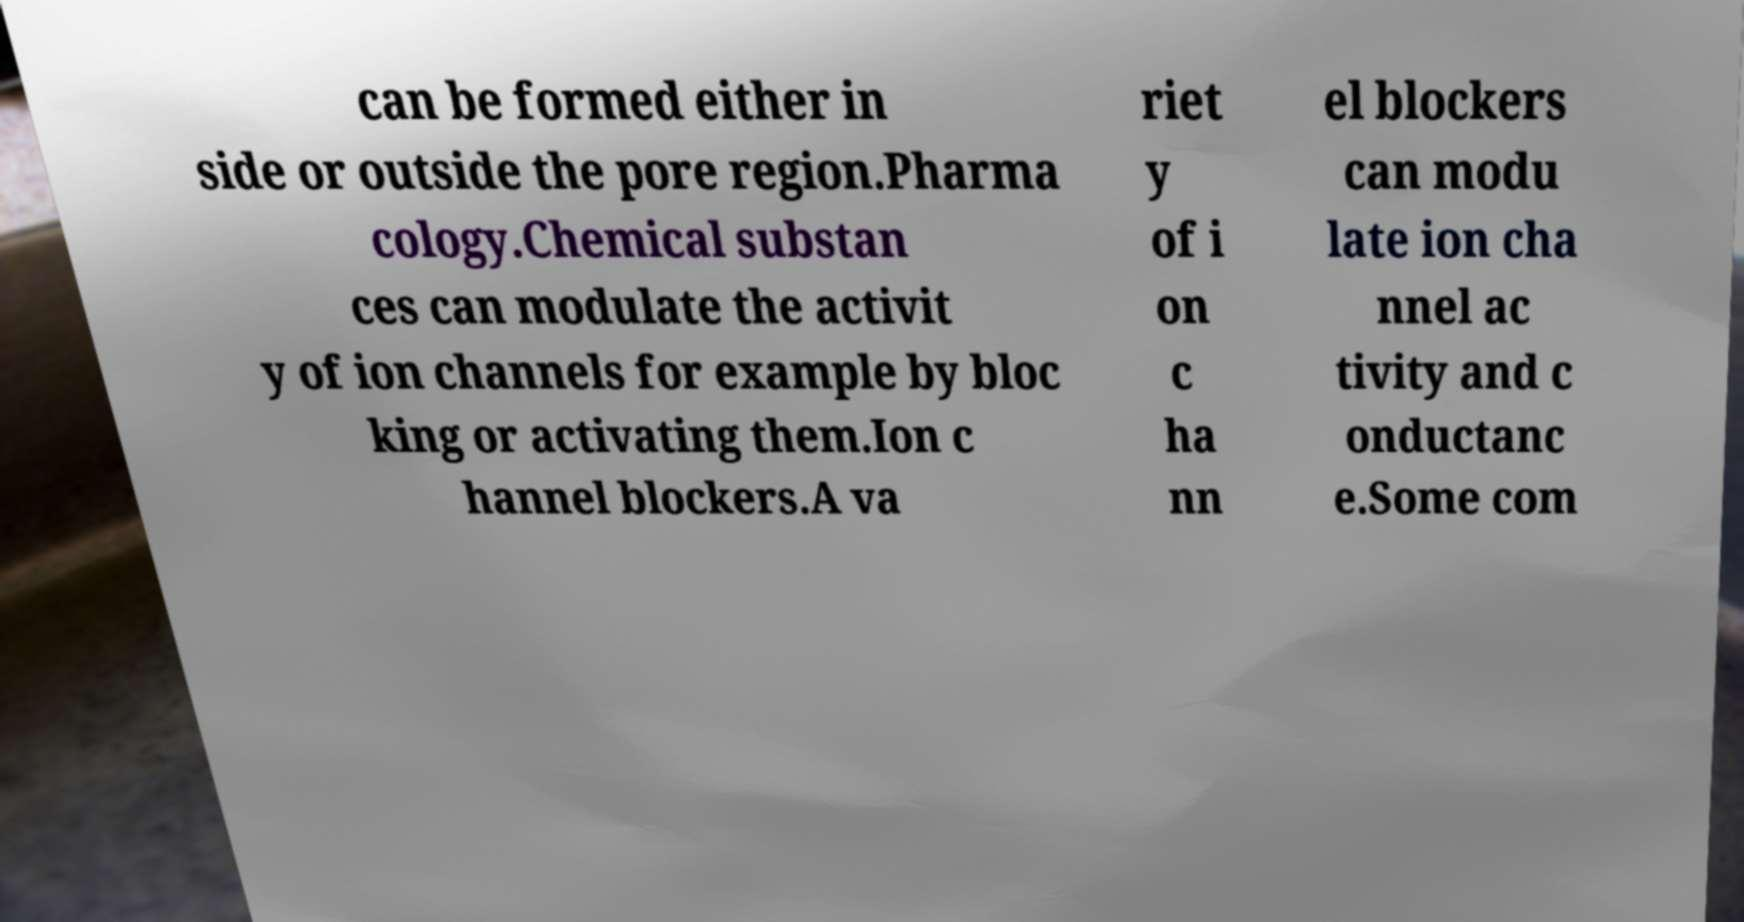Could you extract and type out the text from this image? can be formed either in side or outside the pore region.Pharma cology.Chemical substan ces can modulate the activit y of ion channels for example by bloc king or activating them.Ion c hannel blockers.A va riet y of i on c ha nn el blockers can modu late ion cha nnel ac tivity and c onductanc e.Some com 